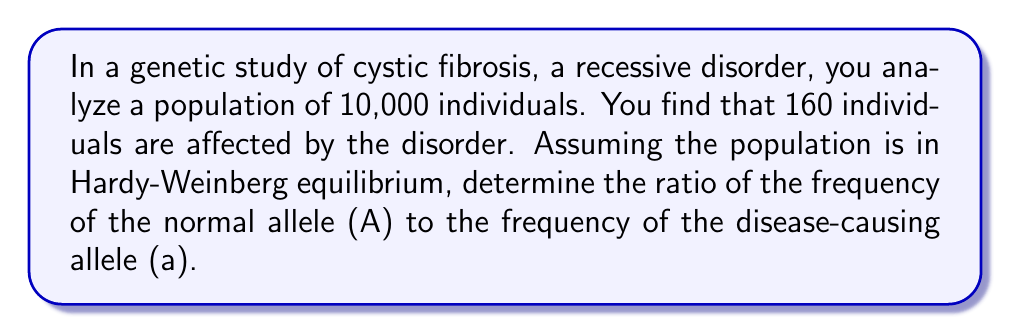Provide a solution to this math problem. To solve this problem, we'll use the Hardy-Weinberg principle and the given information:

1. Let $p$ be the frequency of the normal allele (A) and $q$ be the frequency of the disease-causing allele (a).

2. We know that $p + q = 1$ in a population.

3. In a recessive disorder, affected individuals have the genotype aa. The frequency of affected individuals is $q^2$.

4. Calculate $q^2$:
   $$q^2 = \frac{160}{10000} = 0.016$$

5. Calculate $q$:
   $$q = \sqrt{0.016} = 0.1265$$

6. Calculate $p$:
   $$p = 1 - q = 1 - 0.1265 = 0.8735$$

7. The ratio of $p$ to $q$ is:
   $$\frac{p}{q} = \frac{0.8735}{0.1265} \approx 6.9051$$

8. To simplify this ratio, we can divide both numerator and denominator by 0.1265:
   $$\frac{6.9051}{1} \approx \frac{6.9}{1}$$

Therefore, the ratio of the frequency of the normal allele (A) to the frequency of the disease-causing allele (a) is approximately 6.9 : 1.
Answer: 6.9 : 1 